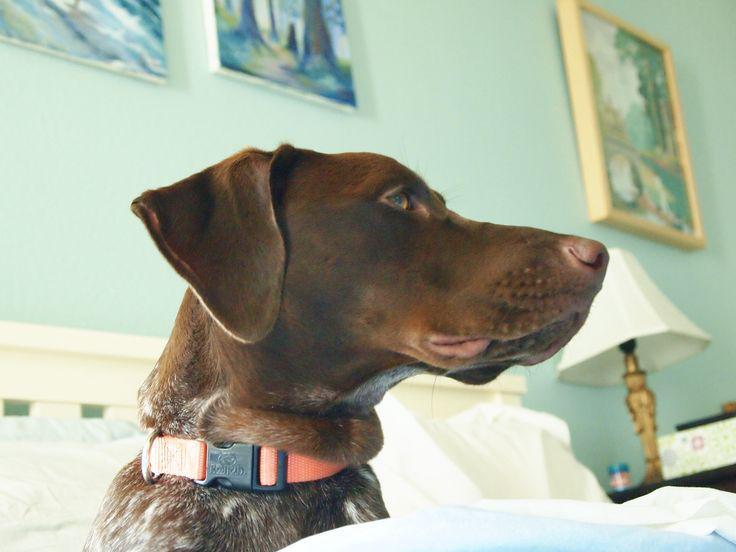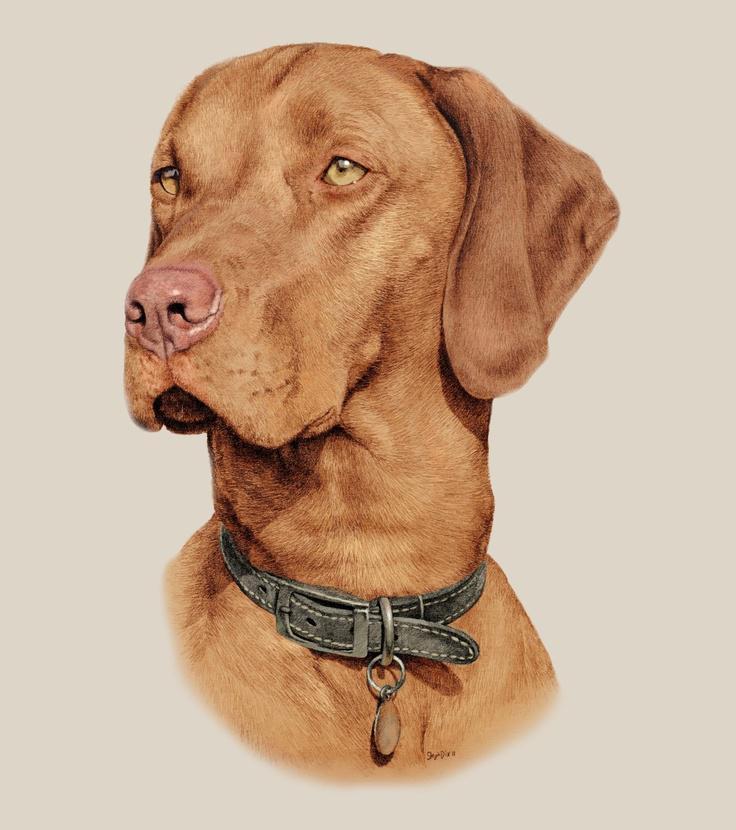The first image is the image on the left, the second image is the image on the right. Analyze the images presented: Is the assertion "The dogs in the left and right images face toward each other, and the combined images include a chocolate lab and and a red-orange lab." valid? Answer yes or no. Yes. 